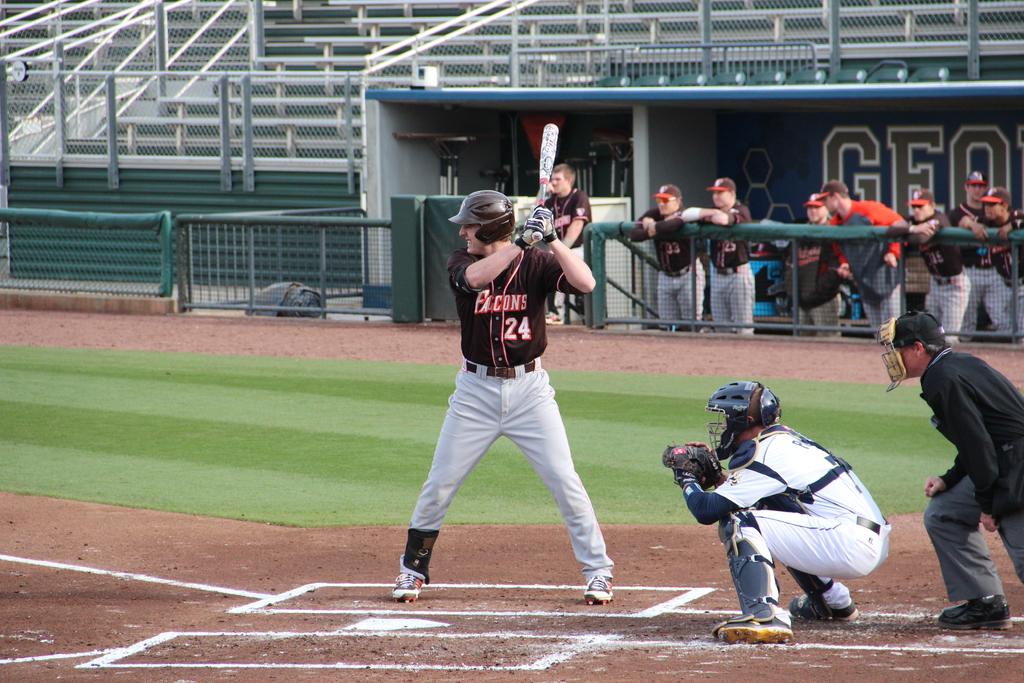What number is on the batter's jersey?
Offer a very short reply. 24. What name is on the batter's jersey?
Your answer should be very brief. Falcons. 